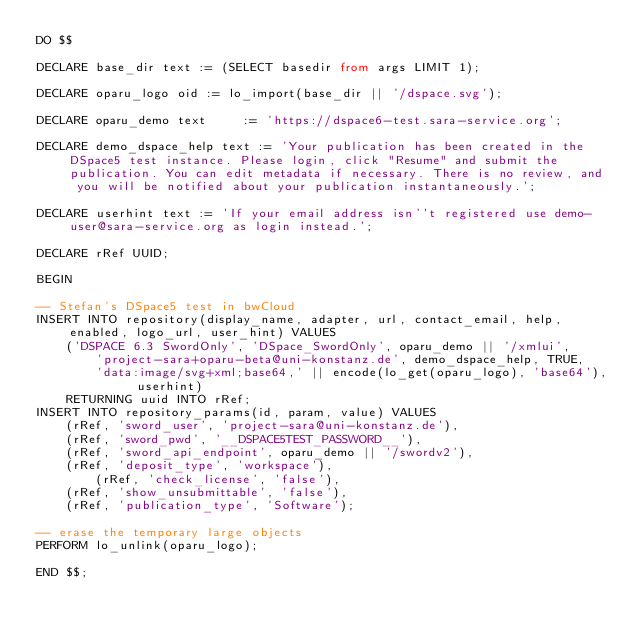Convert code to text. <code><loc_0><loc_0><loc_500><loc_500><_SQL_>DO $$

DECLARE base_dir text := (SELECT basedir from args LIMIT 1);

DECLARE oparu_logo oid := lo_import(base_dir || '/dspace.svg');

DECLARE oparu_demo text     := 'https://dspace6-test.sara-service.org';

DECLARE demo_dspace_help text := 'Your publication has been created in the DSpace5 test instance. Please login, click "Resume" and submit the publication. You can edit metadata if necessary. There is no review, and you will be notified about your publication instantaneously.';

DECLARE userhint text := 'If your email address isn''t registered use demo-user@sara-service.org as login instead.';

DECLARE rRef UUID;

BEGIN

-- Stefan's DSpace5 test in bwCloud 
INSERT INTO repository(display_name, adapter, url, contact_email, help, enabled, logo_url, user_hint) VALUES
	('DSPACE 6.3 SwordOnly', 'DSpace_SwordOnly', oparu_demo || '/xmlui',
		'project-sara+oparu-beta@uni-konstanz.de', demo_dspace_help, TRUE,
		'data:image/svg+xml;base64,' || encode(lo_get(oparu_logo), 'base64'), userhint)
	RETURNING uuid INTO rRef;
INSERT INTO repository_params(id, param, value) VALUES
	(rRef, 'sword_user', 'project-sara@uni-konstanz.de'),
	(rRef, 'sword_pwd', '__DSPACE5TEST_PASSWORD__'),
	(rRef, 'sword_api_endpoint', oparu_demo || '/swordv2'),
	(rRef, 'deposit_type', 'workspace'),
        (rRef, 'check_license', 'false'),
	(rRef, 'show_unsubmittable', 'false'),
	(rRef, 'publication_type', 'Software');

-- erase the temporary large objects
PERFORM lo_unlink(oparu_logo);

END $$;
</code> 